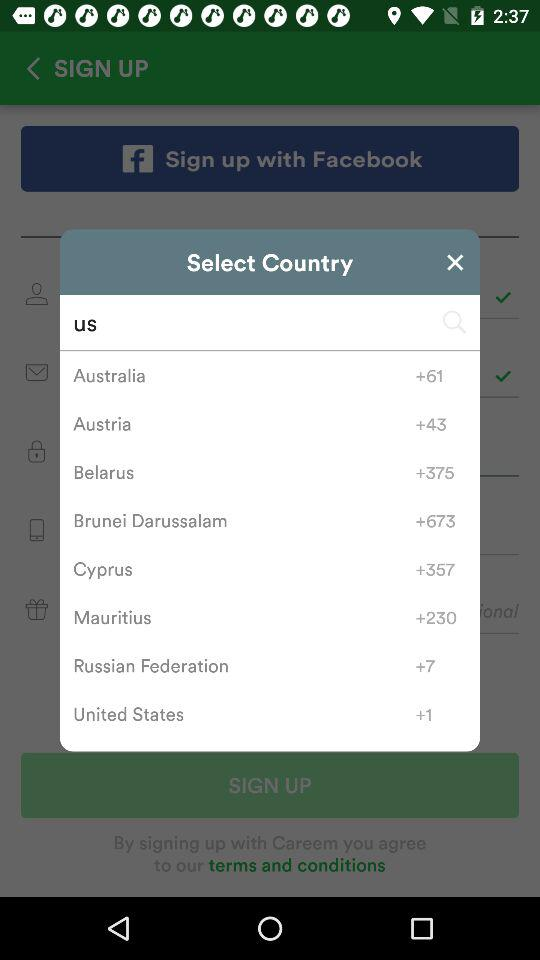What is the country code for Belarus? The country code for Belarus is +375. 